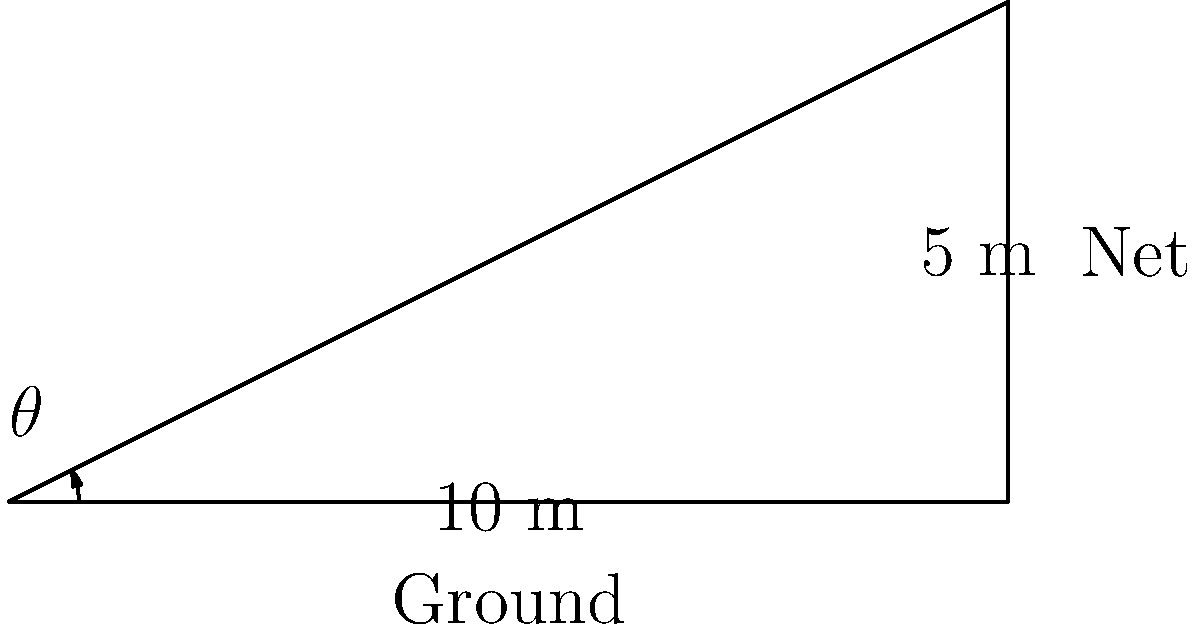During a match, Jasmine Paolini is serving from the baseline. The top of the net is 5 meters high, and the distance from where she's standing to the net is 10 meters. At what angle $\theta$ (in degrees) should she hit the ball for it to just clear the top of the net, assuming she hits it from a height of 2.5 meters? Round your answer to the nearest degree. Let's approach this step-by-step:

1) First, we need to find the height difference between Jasmine's serve point and the top of the net:
   $5 \text{ m} - 2.5 \text{ m} = 2.5 \text{ m}$

2) Now we have a right triangle with:
   - Adjacent side (distance to net) = 10 m
   - Opposite side (height difference) = 2.5 m

3) We need to find the angle $\theta$. In this case, we can use the tangent function:

   $\tan(\theta) = \frac{\text{opposite}}{\text{adjacent}} = \frac{2.5}{10}$

4) To find $\theta$, we need to use the inverse tangent (arctangent) function:

   $\theta = \arctan(\frac{2.5}{10})$

5) Using a calculator or computer:

   $\theta = \arctan(0.25) \approx 14.0362^\circ$

6) Rounding to the nearest degree:

   $\theta \approx 14^\circ$
Answer: $14^\circ$ 